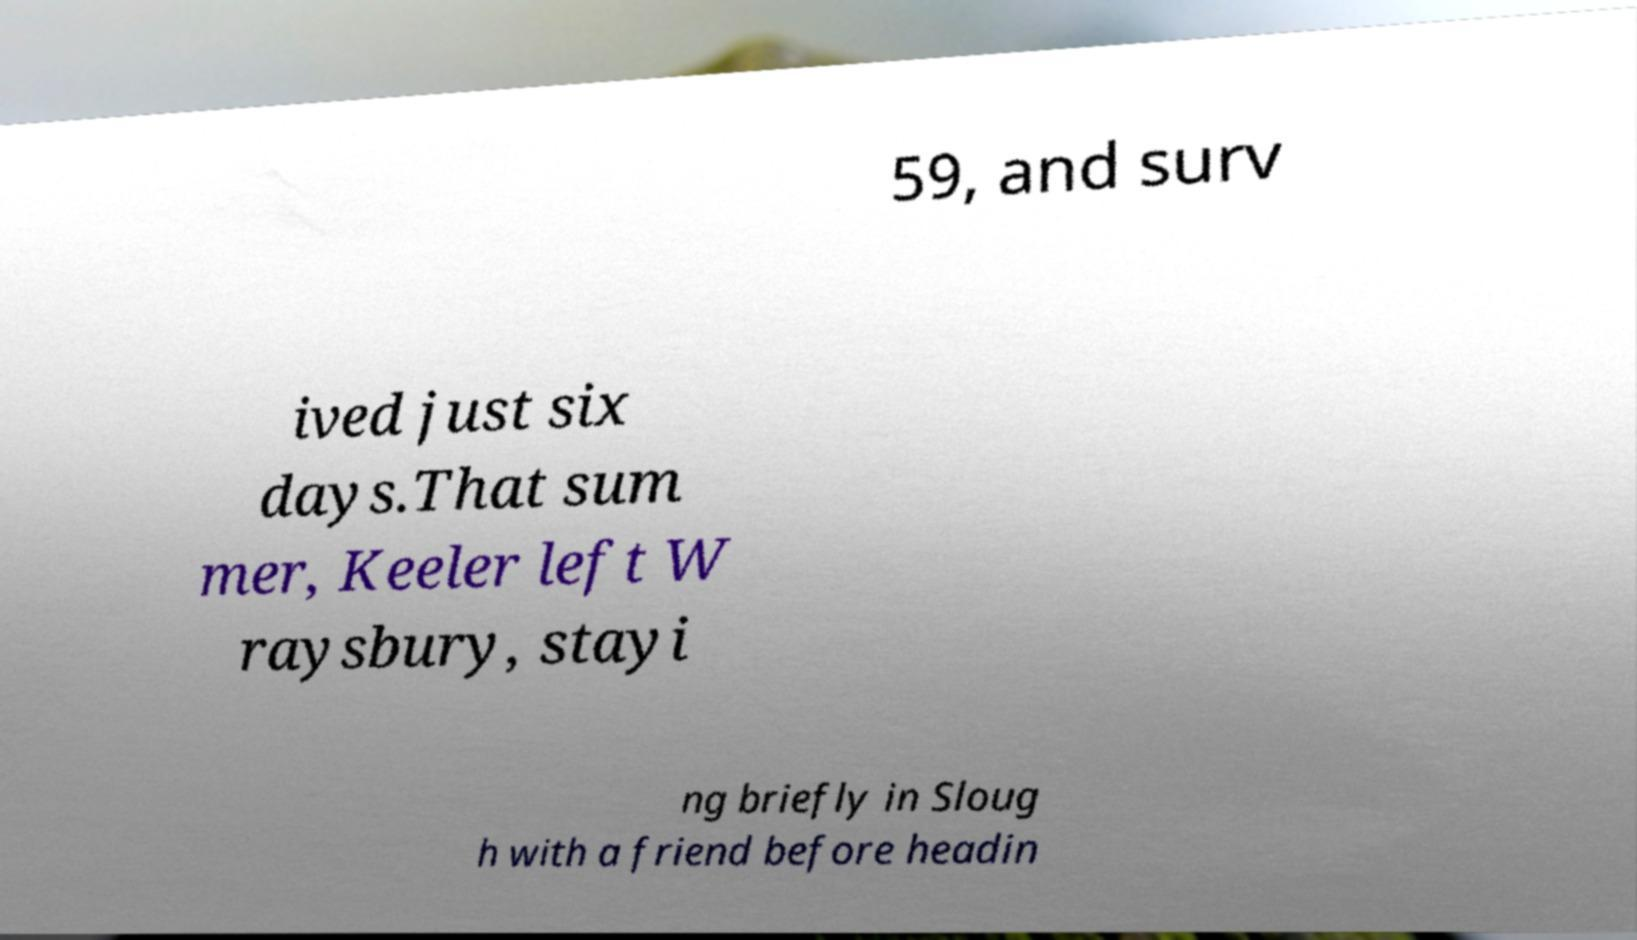What messages or text are displayed in this image? I need them in a readable, typed format. 59, and surv ived just six days.That sum mer, Keeler left W raysbury, stayi ng briefly in Sloug h with a friend before headin 